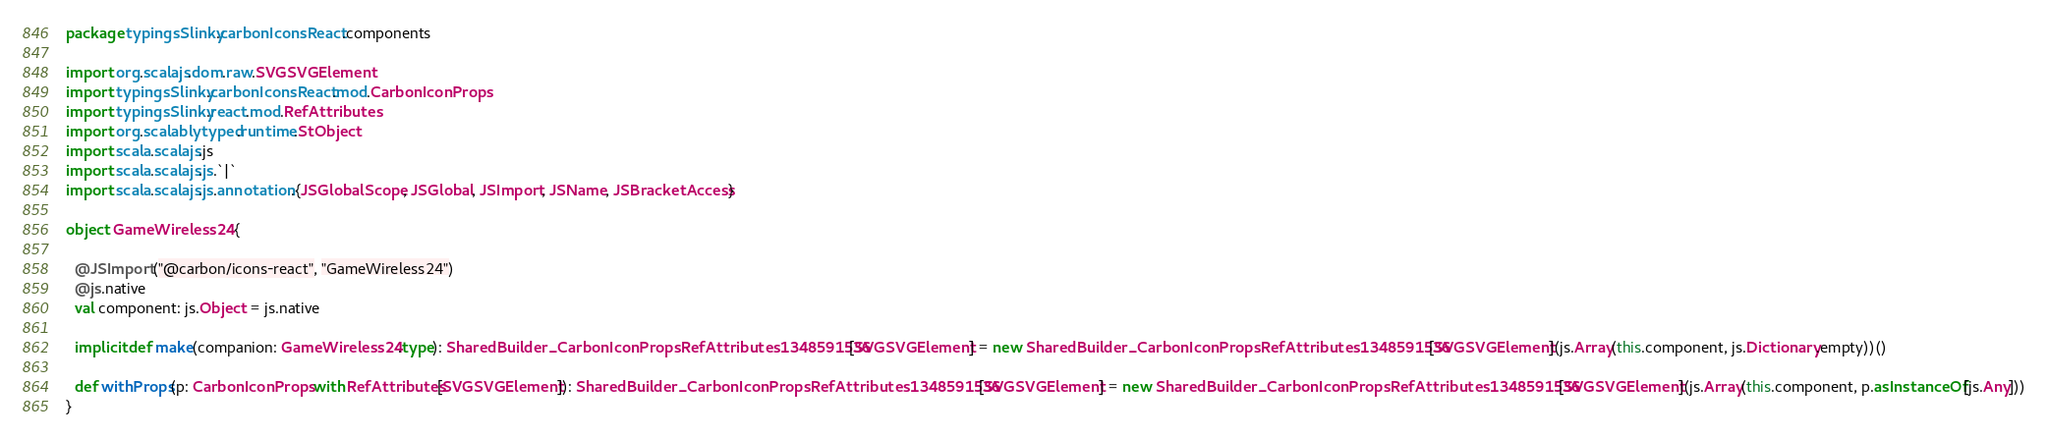Convert code to text. <code><loc_0><loc_0><loc_500><loc_500><_Scala_>package typingsSlinky.carbonIconsReact.components

import org.scalajs.dom.raw.SVGSVGElement
import typingsSlinky.carbonIconsReact.mod.CarbonIconProps
import typingsSlinky.react.mod.RefAttributes
import org.scalablytyped.runtime.StObject
import scala.scalajs.js
import scala.scalajs.js.`|`
import scala.scalajs.js.annotation.{JSGlobalScope, JSGlobal, JSImport, JSName, JSBracketAccess}

object GameWireless24 {
  
  @JSImport("@carbon/icons-react", "GameWireless24")
  @js.native
  val component: js.Object = js.native
  
  implicit def make(companion: GameWireless24.type): SharedBuilder_CarbonIconPropsRefAttributes1348591536[SVGSVGElement] = new SharedBuilder_CarbonIconPropsRefAttributes1348591536[SVGSVGElement](js.Array(this.component, js.Dictionary.empty))()
  
  def withProps(p: CarbonIconProps with RefAttributes[SVGSVGElement]): SharedBuilder_CarbonIconPropsRefAttributes1348591536[SVGSVGElement] = new SharedBuilder_CarbonIconPropsRefAttributes1348591536[SVGSVGElement](js.Array(this.component, p.asInstanceOf[js.Any]))
}
</code> 